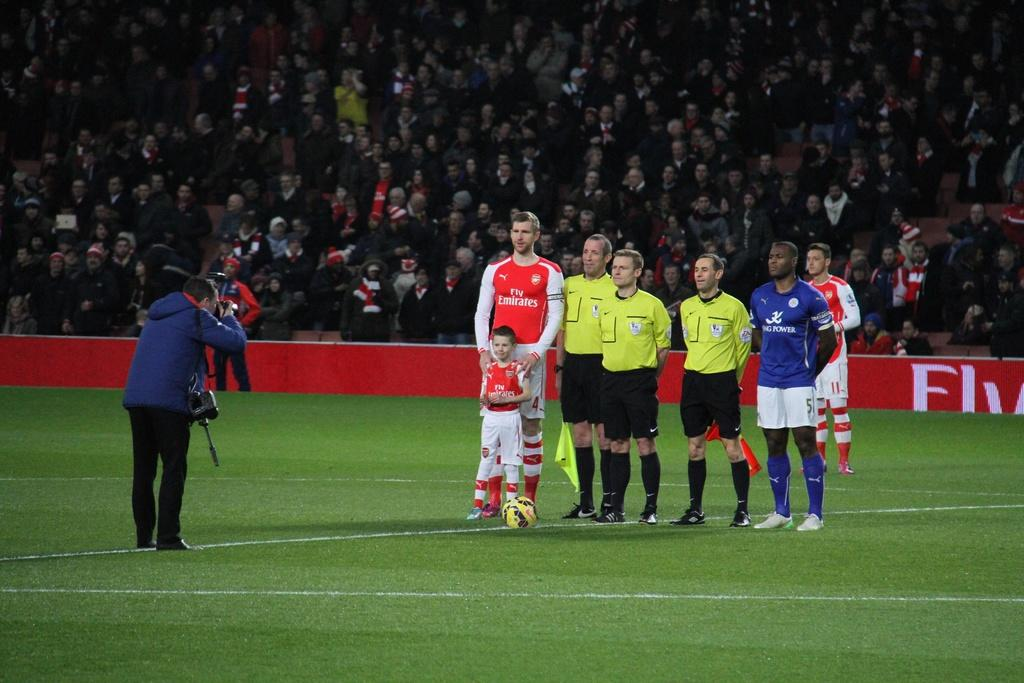Provide a one-sentence caption for the provided image. some sports players getting their picture taken on a game field, one man has Fly Emirates on his shirt and the other one has King Power. 